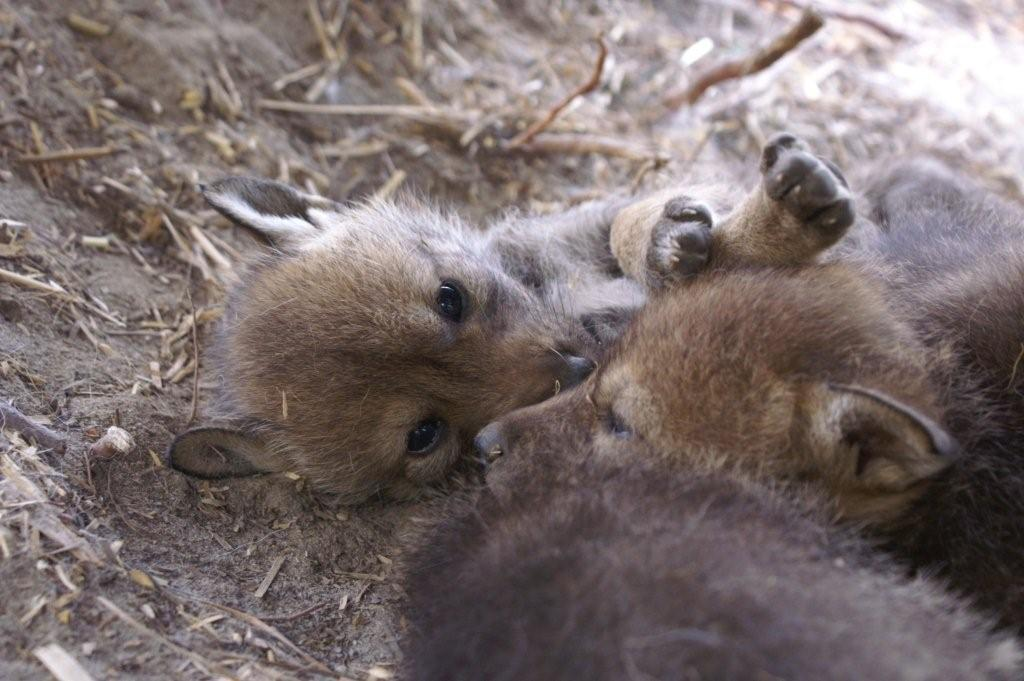What type of living organisms can be seen in the image? There are animals in the image. What is the position of the animals in the image? The animals are laying on the ground. What type of drain can be seen in the image? There is no drain present in the image. What type of toy can be seen in the image? There is no toy present in the image. 